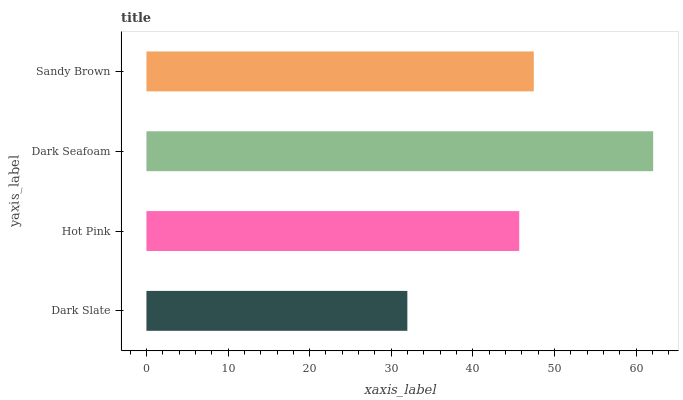Is Dark Slate the minimum?
Answer yes or no. Yes. Is Dark Seafoam the maximum?
Answer yes or no. Yes. Is Hot Pink the minimum?
Answer yes or no. No. Is Hot Pink the maximum?
Answer yes or no. No. Is Hot Pink greater than Dark Slate?
Answer yes or no. Yes. Is Dark Slate less than Hot Pink?
Answer yes or no. Yes. Is Dark Slate greater than Hot Pink?
Answer yes or no. No. Is Hot Pink less than Dark Slate?
Answer yes or no. No. Is Sandy Brown the high median?
Answer yes or no. Yes. Is Hot Pink the low median?
Answer yes or no. Yes. Is Hot Pink the high median?
Answer yes or no. No. Is Dark Slate the low median?
Answer yes or no. No. 